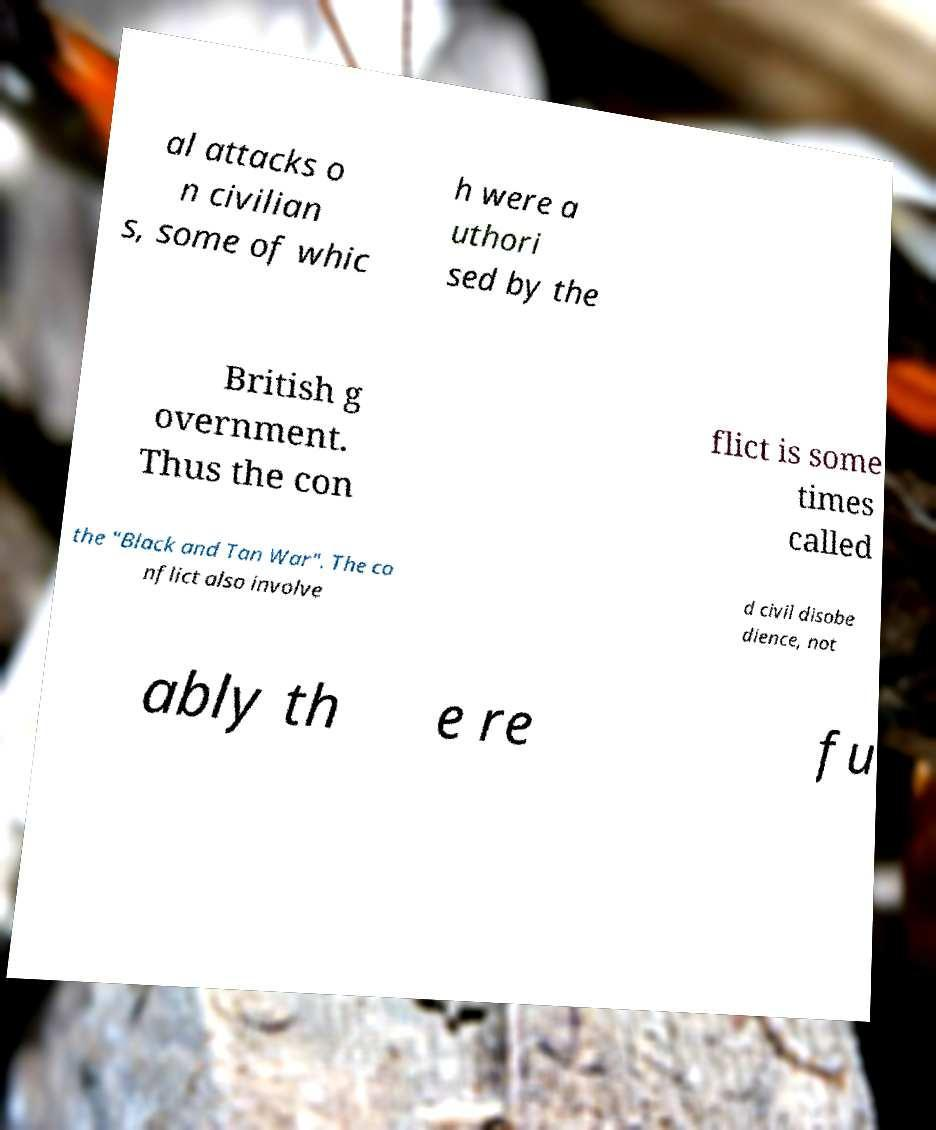What messages or text are displayed in this image? I need them in a readable, typed format. al attacks o n civilian s, some of whic h were a uthori sed by the British g overnment. Thus the con flict is some times called the "Black and Tan War". The co nflict also involve d civil disobe dience, not ably th e re fu 